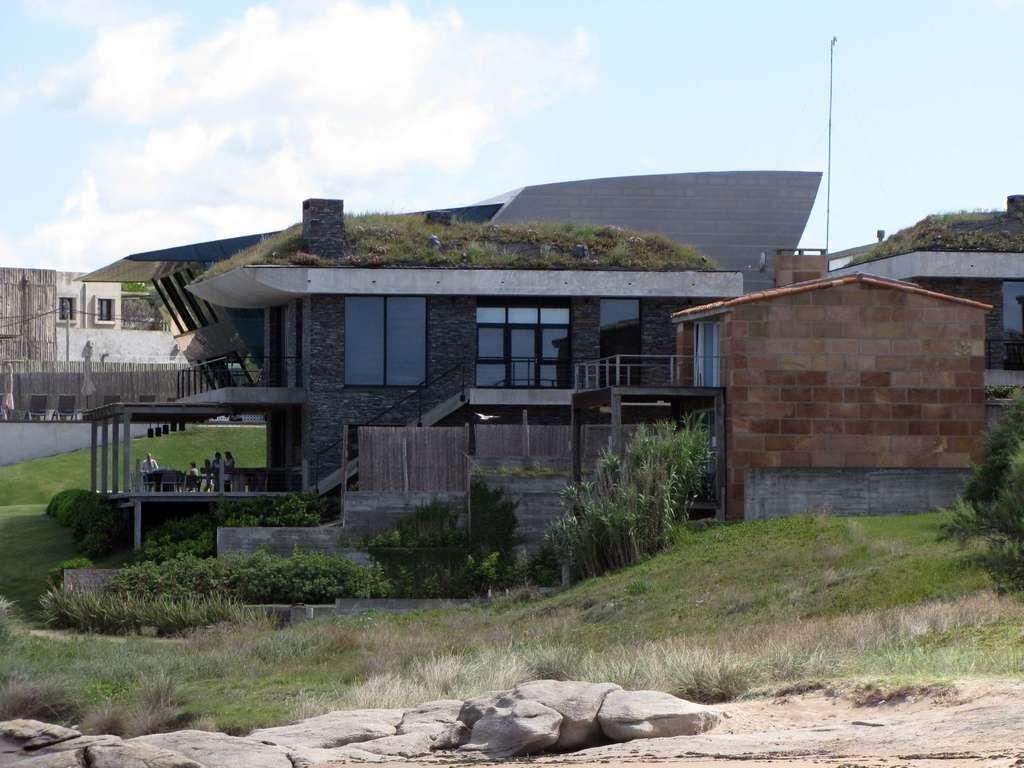How many people are in the image? There is a group of people in the image, but the exact number is not specified. What else can be seen in the image besides the people? There are plants, buildings, poles, and rocks in the image. Can you describe the plants in the image? The provided facts do not specify the type or characteristics of the plants. What are the poles used for in the image? The purpose of the poles in the image is not mentioned in the provided facts. What brand of toothpaste is being advertised on the floor in the image? There is no toothpaste or advertisement present on the floor in the image. 